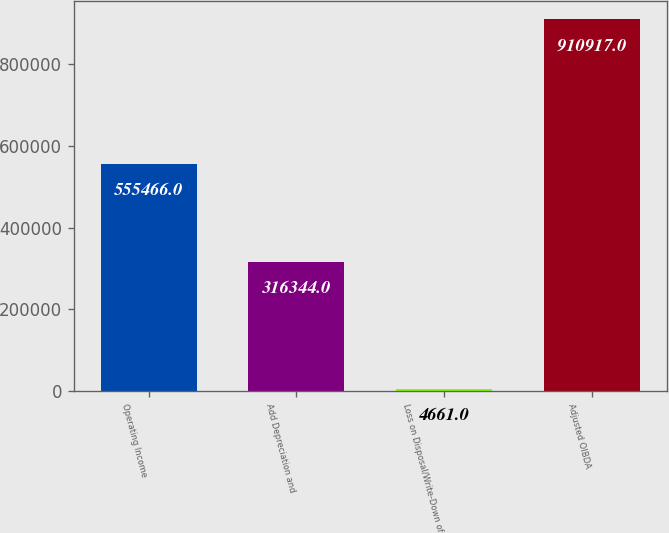Convert chart to OTSL. <chart><loc_0><loc_0><loc_500><loc_500><bar_chart><fcel>Operating Income<fcel>Add Depreciation and<fcel>Loss on Disposal/Write-Down of<fcel>Adjusted OIBDA<nl><fcel>555466<fcel>316344<fcel>4661<fcel>910917<nl></chart> 